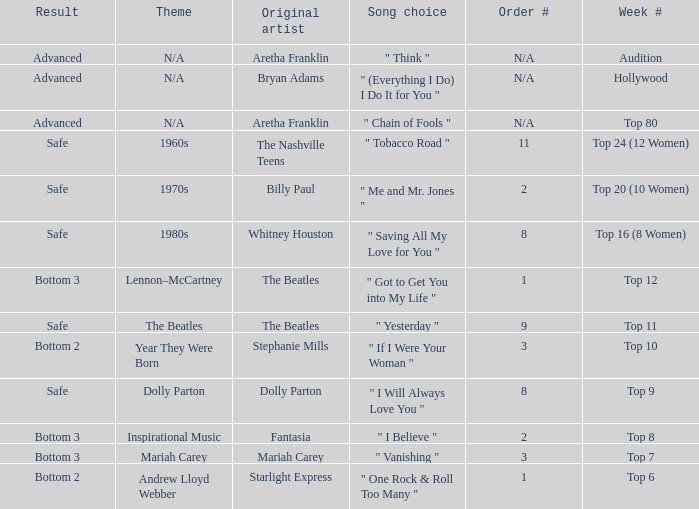Name the week number for andrew lloyd webber Top 6. Would you be able to parse every entry in this table? {'header': ['Result', 'Theme', 'Original artist', 'Song choice', 'Order #', 'Week #'], 'rows': [['Advanced', 'N/A', 'Aretha Franklin', '" Think "', 'N/A', 'Audition'], ['Advanced', 'N/A', 'Bryan Adams', '" (Everything I Do) I Do It for You "', 'N/A', 'Hollywood'], ['Advanced', 'N/A', 'Aretha Franklin', '" Chain of Fools "', 'N/A', 'Top 80'], ['Safe', '1960s', 'The Nashville Teens', '" Tobacco Road "', '11', 'Top 24 (12 Women)'], ['Safe', '1970s', 'Billy Paul', '" Me and Mr. Jones "', '2', 'Top 20 (10 Women)'], ['Safe', '1980s', 'Whitney Houston', '" Saving All My Love for You "', '8', 'Top 16 (8 Women)'], ['Bottom 3', 'Lennon–McCartney', 'The Beatles', '" Got to Get You into My Life "', '1', 'Top 12'], ['Safe', 'The Beatles', 'The Beatles', '" Yesterday "', '9', 'Top 11'], ['Bottom 2', 'Year They Were Born', 'Stephanie Mills', '" If I Were Your Woman "', '3', 'Top 10'], ['Safe', 'Dolly Parton', 'Dolly Parton', '" I Will Always Love You "', '8', 'Top 9'], ['Bottom 3', 'Inspirational Music', 'Fantasia', '" I Believe "', '2', 'Top 8'], ['Bottom 3', 'Mariah Carey', 'Mariah Carey', '" Vanishing "', '3', 'Top 7'], ['Bottom 2', 'Andrew Lloyd Webber', 'Starlight Express', '" One Rock & Roll Too Many "', '1', 'Top 6']]} 